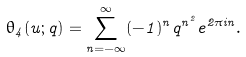Convert formula to latex. <formula><loc_0><loc_0><loc_500><loc_500>\theta _ { 4 } ( u ; q ) = \sum _ { n = - \infty } ^ { \infty } ( - 1 ) ^ { n } q ^ { n ^ { 2 } } e ^ { 2 \pi i n } .</formula> 